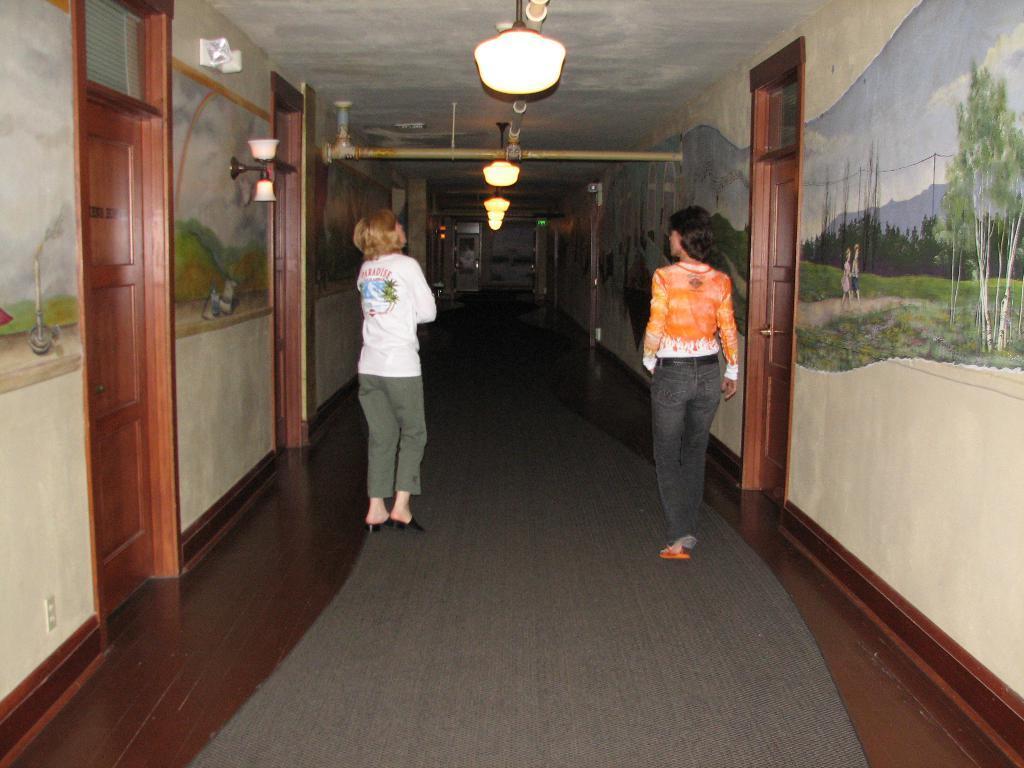Could you give a brief overview of what you see in this image? In this image, on the right side, we can see a woman walking on the mat. On the left side, we can also see another woman standing on the mat. On the right side and left side, we can see some doors which are closed and paintings on the wall. At the top, we can see a room with few lights. 